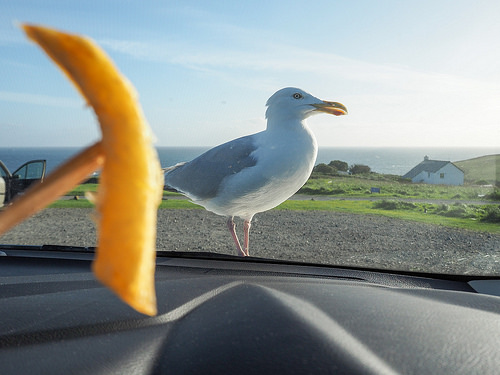<image>
Can you confirm if the french fry is next to the sea gull? Yes. The french fry is positioned adjacent to the sea gull, located nearby in the same general area. 